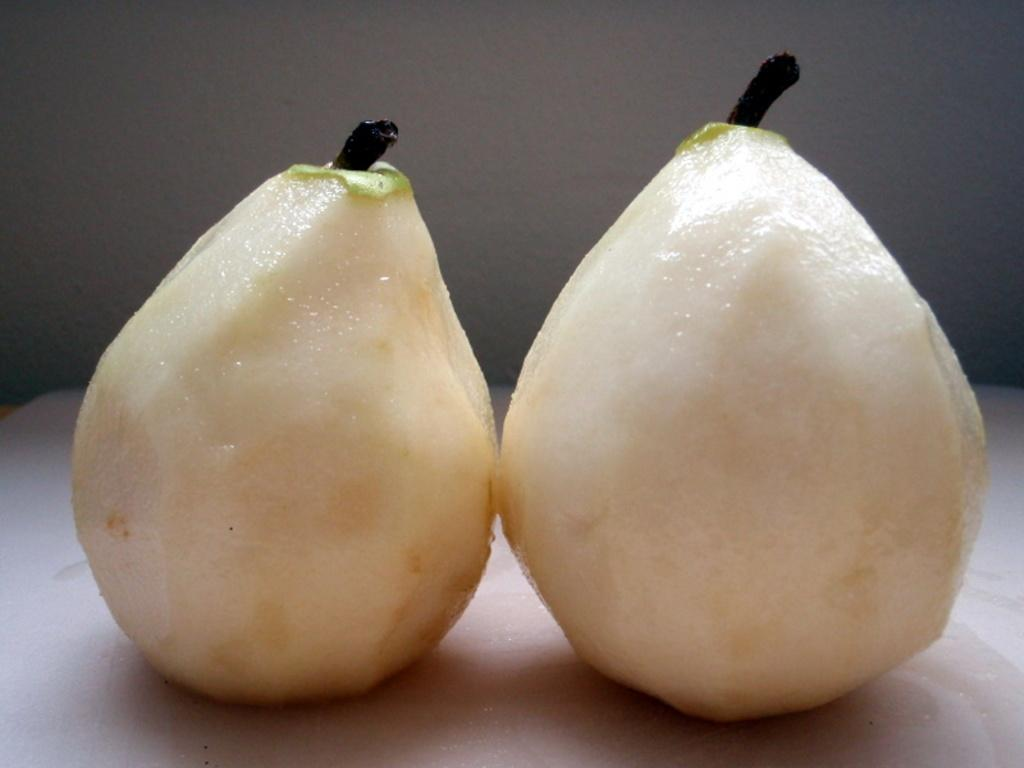What type of objects can be seen in the image? There are food items in the image. Where are the food items placed? The food items are on a white object. What can be seen in the background of the image? There is a wall visible in the background of the image. How many cups can be seen in the image? There are no cups present in the image. What type of trees are visible in the image? There are no trees visible in the image. 